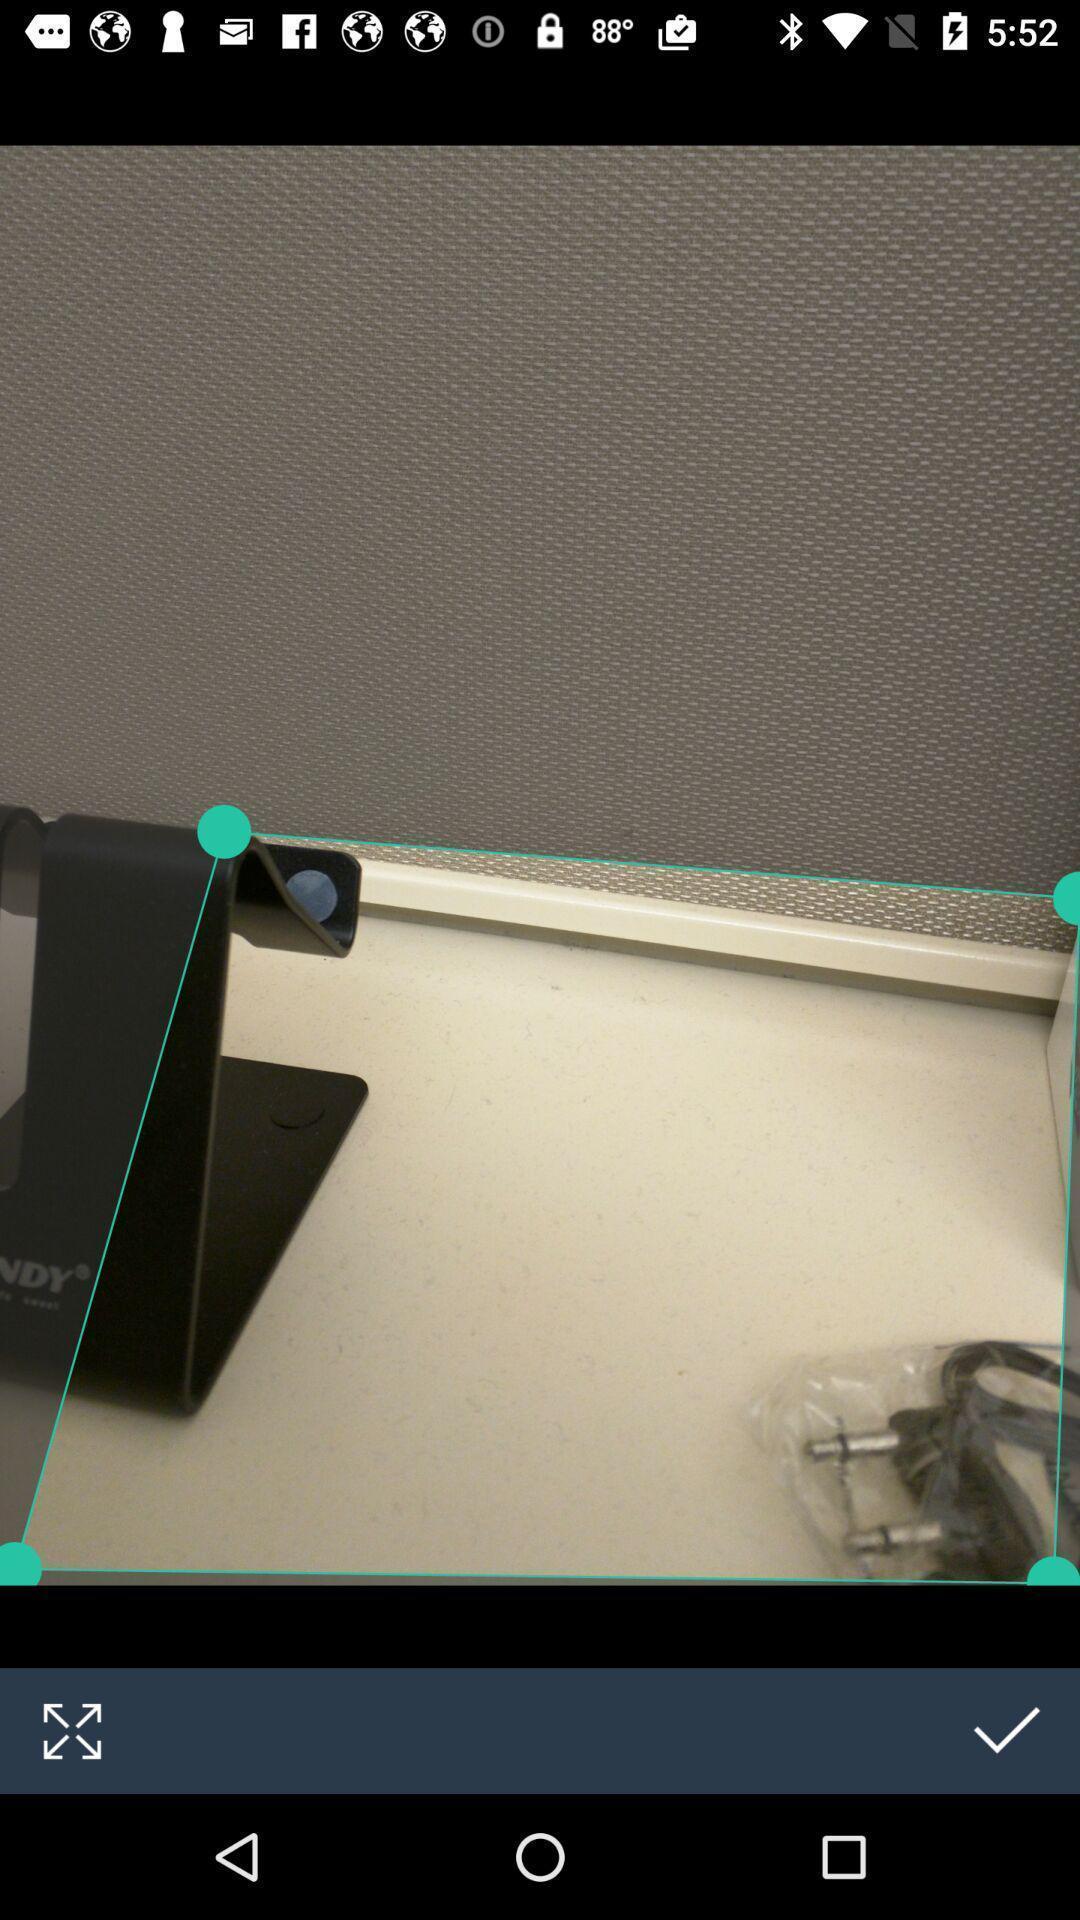What is the overall content of this screenshot? Screen shows an image with edit option. 